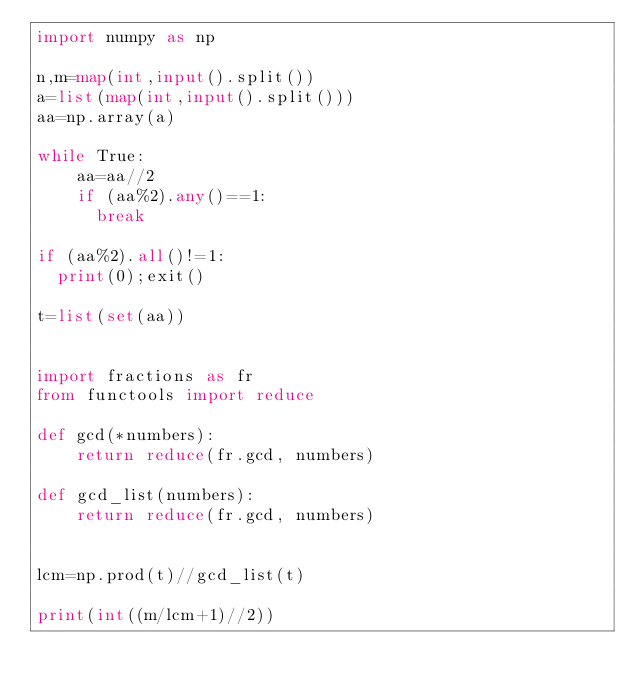<code> <loc_0><loc_0><loc_500><loc_500><_Python_>import numpy as np

n,m=map(int,input().split())
a=list(map(int,input().split()))
aa=np.array(a)

while True:
    aa=aa//2
    if (aa%2).any()==1:
      break
     
if (aa%2).all()!=1:
  print(0);exit()

t=list(set(aa))


import fractions as fr
from functools import reduce

def gcd(*numbers):
    return reduce(fr.gcd, numbers)

def gcd_list(numbers):
    return reduce(fr.gcd, numbers)


lcm=np.prod(t)//gcd_list(t)

print(int((m/lcm+1)//2))

</code> 